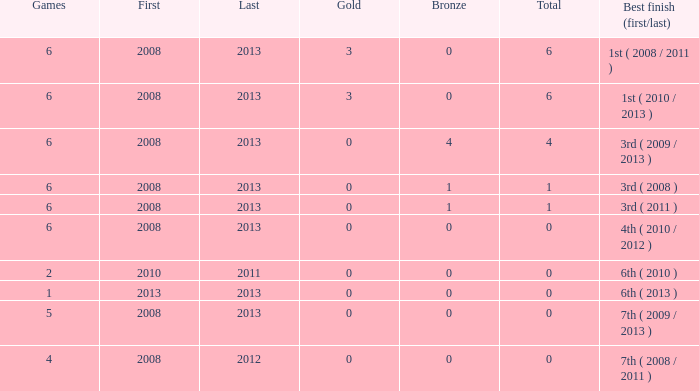What is the fewest number of medals associated with under 6 games and over 0 golds? None. 